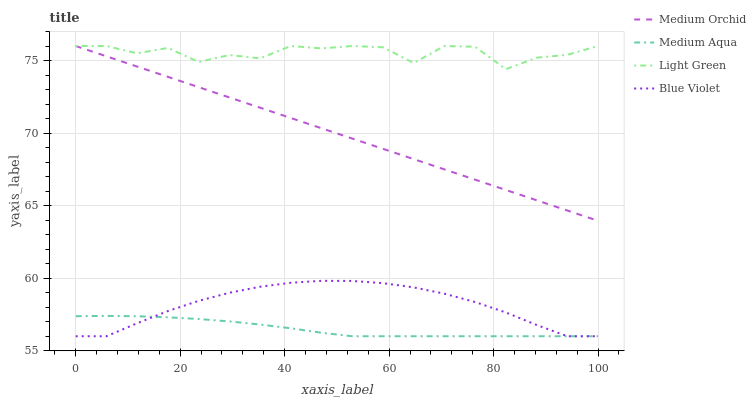Does Medium Aqua have the minimum area under the curve?
Answer yes or no. Yes. Does Light Green have the maximum area under the curve?
Answer yes or no. Yes. Does Blue Violet have the minimum area under the curve?
Answer yes or no. No. Does Blue Violet have the maximum area under the curve?
Answer yes or no. No. Is Medium Orchid the smoothest?
Answer yes or no. Yes. Is Light Green the roughest?
Answer yes or no. Yes. Is Medium Aqua the smoothest?
Answer yes or no. No. Is Medium Aqua the roughest?
Answer yes or no. No. Does Medium Aqua have the lowest value?
Answer yes or no. Yes. Does Light Green have the lowest value?
Answer yes or no. No. Does Light Green have the highest value?
Answer yes or no. Yes. Does Blue Violet have the highest value?
Answer yes or no. No. Is Blue Violet less than Light Green?
Answer yes or no. Yes. Is Medium Orchid greater than Blue Violet?
Answer yes or no. Yes. Does Medium Orchid intersect Light Green?
Answer yes or no. Yes. Is Medium Orchid less than Light Green?
Answer yes or no. No. Is Medium Orchid greater than Light Green?
Answer yes or no. No. Does Blue Violet intersect Light Green?
Answer yes or no. No. 